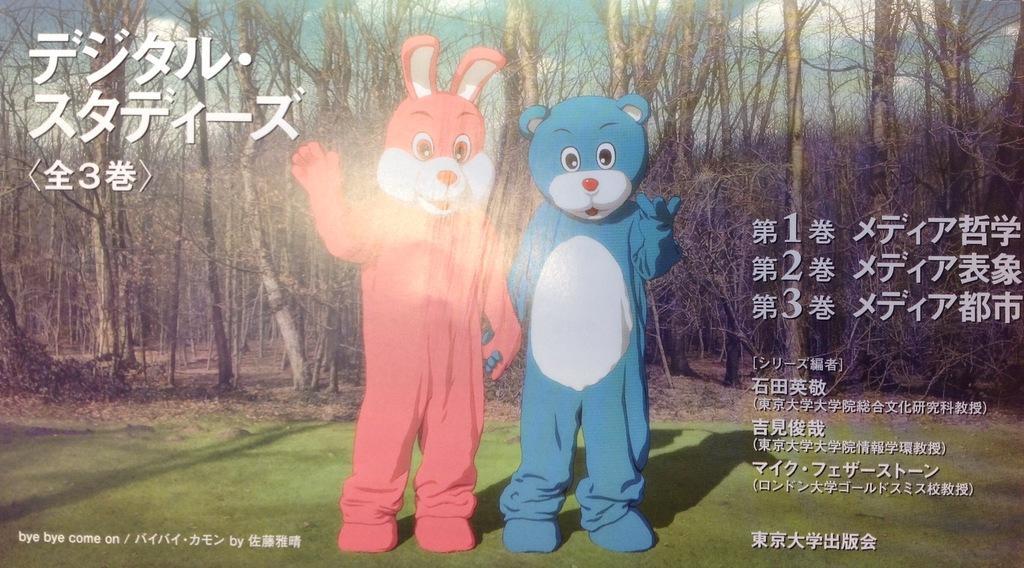How would you summarize this image in a sentence or two? In this picture we can see two men standing in the front and wearing cartoon costumes and standing on the ground. Behind there are some dry trees. On the right corner we can see some matter written in the Chinese language. 